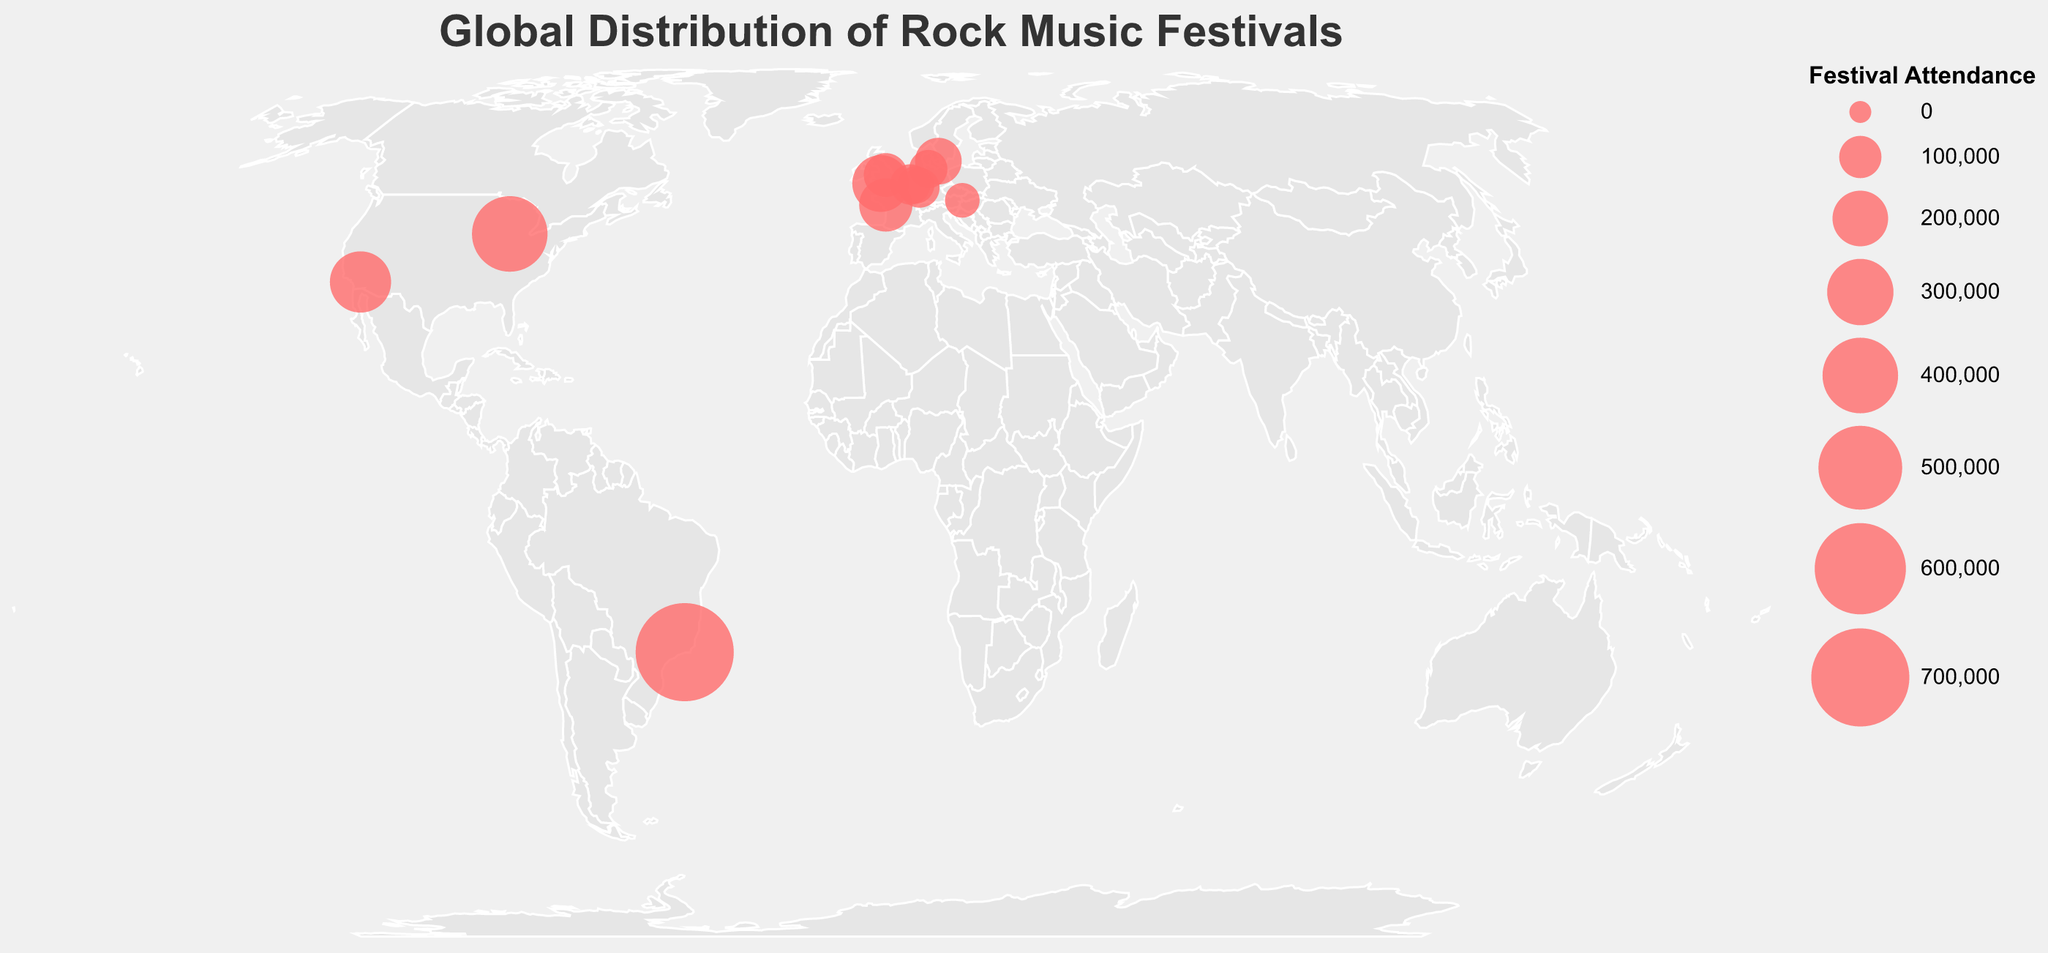What is the title of the figure? The title of a figure is usually located at the top and gives an overview of what the plot is about. In this case, we are told that the title is "Global Distribution of Rock Music Festivals."
Answer: Global Distribution of Rock Music Festivals Which festival has the highest attendance? To find the festival with the highest attendance, we look for the largest circle on the map. According to the data, "Rock in Rio" in Brazil has the highest attendance with 700,000 people.
Answer: Rock in Rio How many rock festivals are displayed on the map? We need to count each data point represented by a circle on the map. According to the provided data, there are 12 rock festivals.
Answer: 12 Which country is hosting the most rock music festivals in the dataset? Look at the data and count how many festivals are being held in each country. The country with the highest number of festivals will be the answer. The United Kingdom and Germany each host 2 festivals.
Answer: United Kingdom and Germany What is the total attendance for all festivals in Germany? To find the total attendance in Germany, sum up the values for each festival held there. "Wacken Open Air" has 75,000, and "Rock am Ring" has 85,000. So, 75,000 + 85,000 = 160,000.
Answer: 160,000 Which festival has the smallest attendance, and what is the attendance figure? To find the smallest attendance, look for the smallest circle on the map. According to the data, "Nova Rock" in Austria has the smallest attendance with 55,000 people.
Answer: Nova Rock, 55,000 Are there any festivals close to each other geographically? To determine this, observe the positions of the circles on the map. “Download Festival” in the UK and “Glastonbury Festival” in the UK are relatively close to each other, as are “Rock am Ring” and “Rock Werchter” in Germany and Belgium respectively.
Answer: Yes, Download Festival and Glastonbury Festival in the UK; Rock am Ring and Rock Werchter in Germany and Belgium What is the average attendance for the festivals held in the USA? To calculate the average attendance, sum up the values for "Coachella" (250,000) and "Lollapalooza" (400,000), then divide by the number of festivals (2). (250,000 + 400,000) / 2 = 325,000.
Answer: 325,000 Which continent hosts the most rock music festivals according to the data? Identify the continents where each country is located and count the number of festivals per continent. Europe has the highest number because the majority of the festivals are in European countries like the UK, Germany, France, Belgium, Netherlands, Denmark, and Austria.
Answer: Europe 